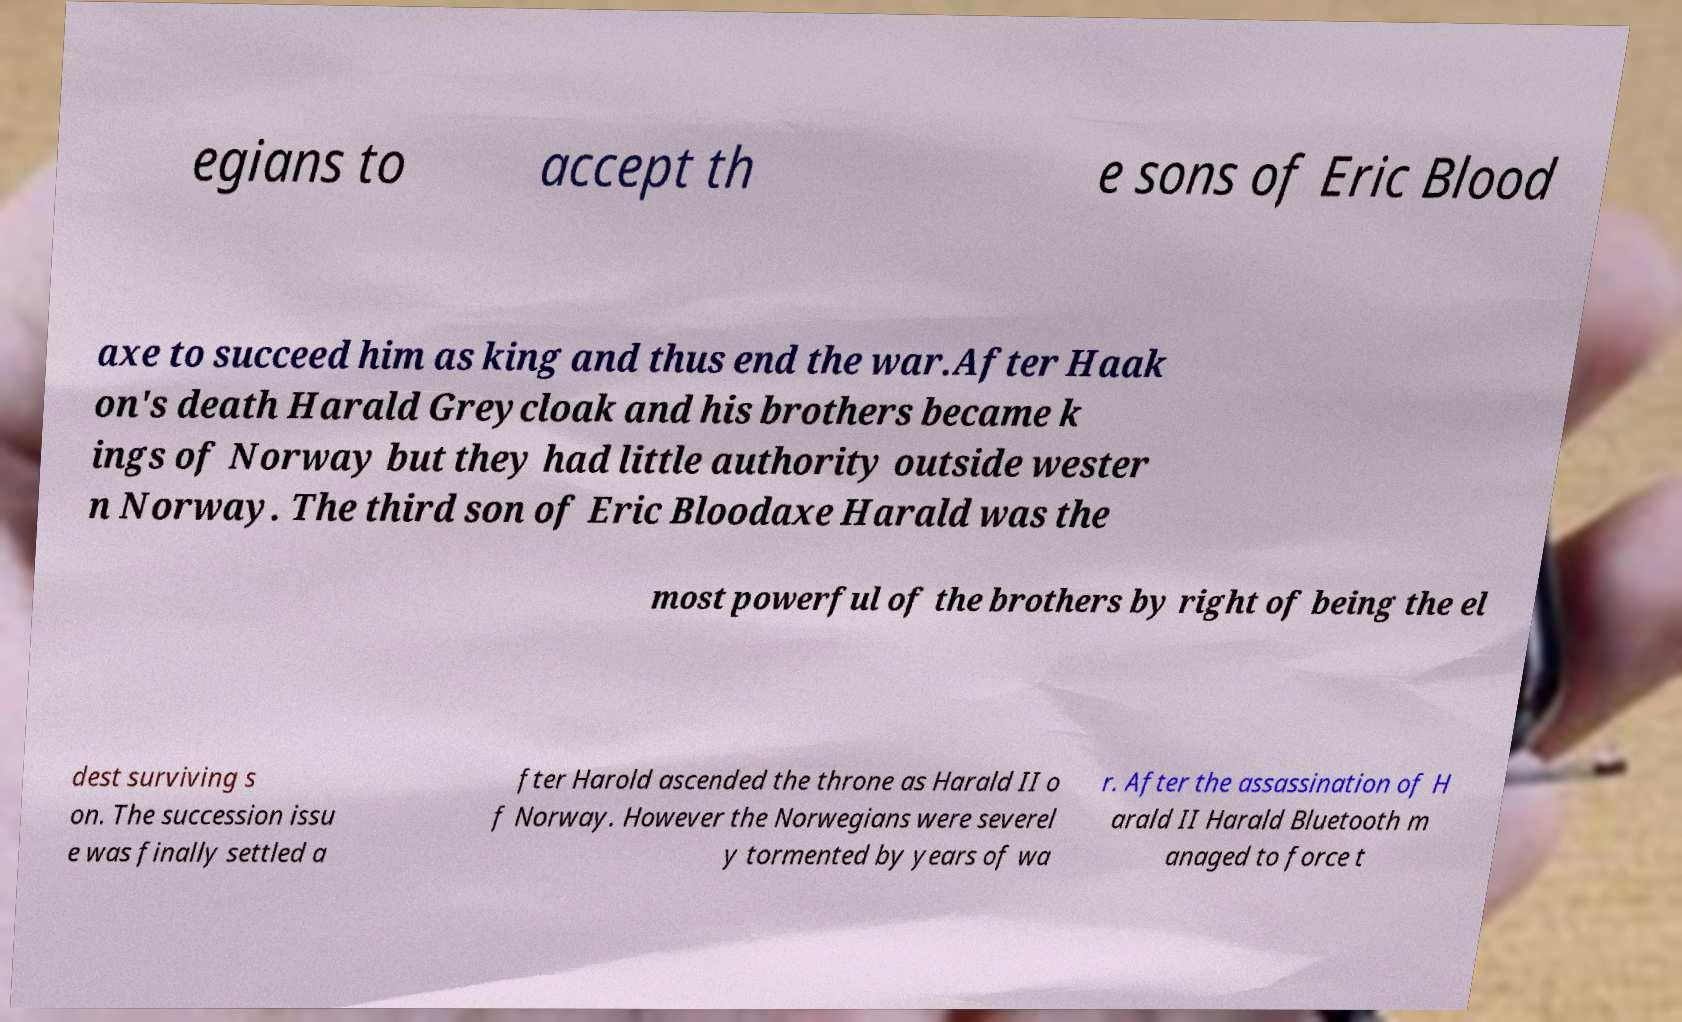For documentation purposes, I need the text within this image transcribed. Could you provide that? egians to accept th e sons of Eric Blood axe to succeed him as king and thus end the war.After Haak on's death Harald Greycloak and his brothers became k ings of Norway but they had little authority outside wester n Norway. The third son of Eric Bloodaxe Harald was the most powerful of the brothers by right of being the el dest surviving s on. The succession issu e was finally settled a fter Harold ascended the throne as Harald II o f Norway. However the Norwegians were severel y tormented by years of wa r. After the assassination of H arald II Harald Bluetooth m anaged to force t 